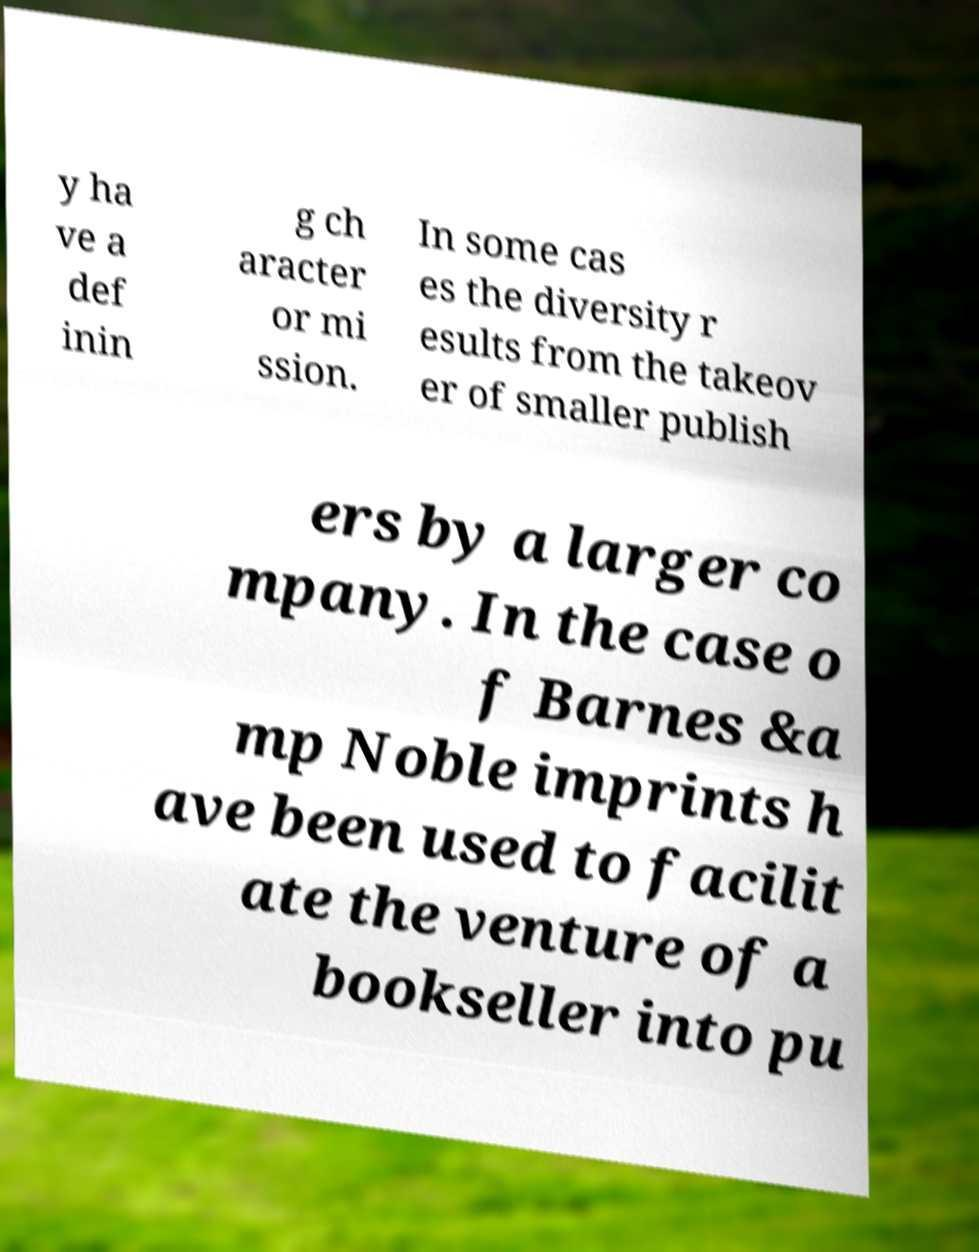Please read and relay the text visible in this image. What does it say? y ha ve a def inin g ch aracter or mi ssion. In some cas es the diversity r esults from the takeov er of smaller publish ers by a larger co mpany. In the case o f Barnes &a mp Noble imprints h ave been used to facilit ate the venture of a bookseller into pu 